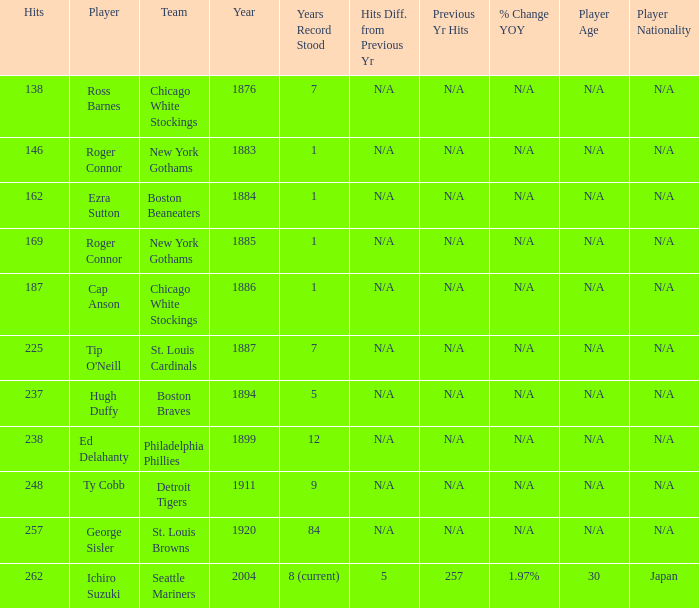Name the least hits for year less than 1920 and player of ed delahanty 238.0. 